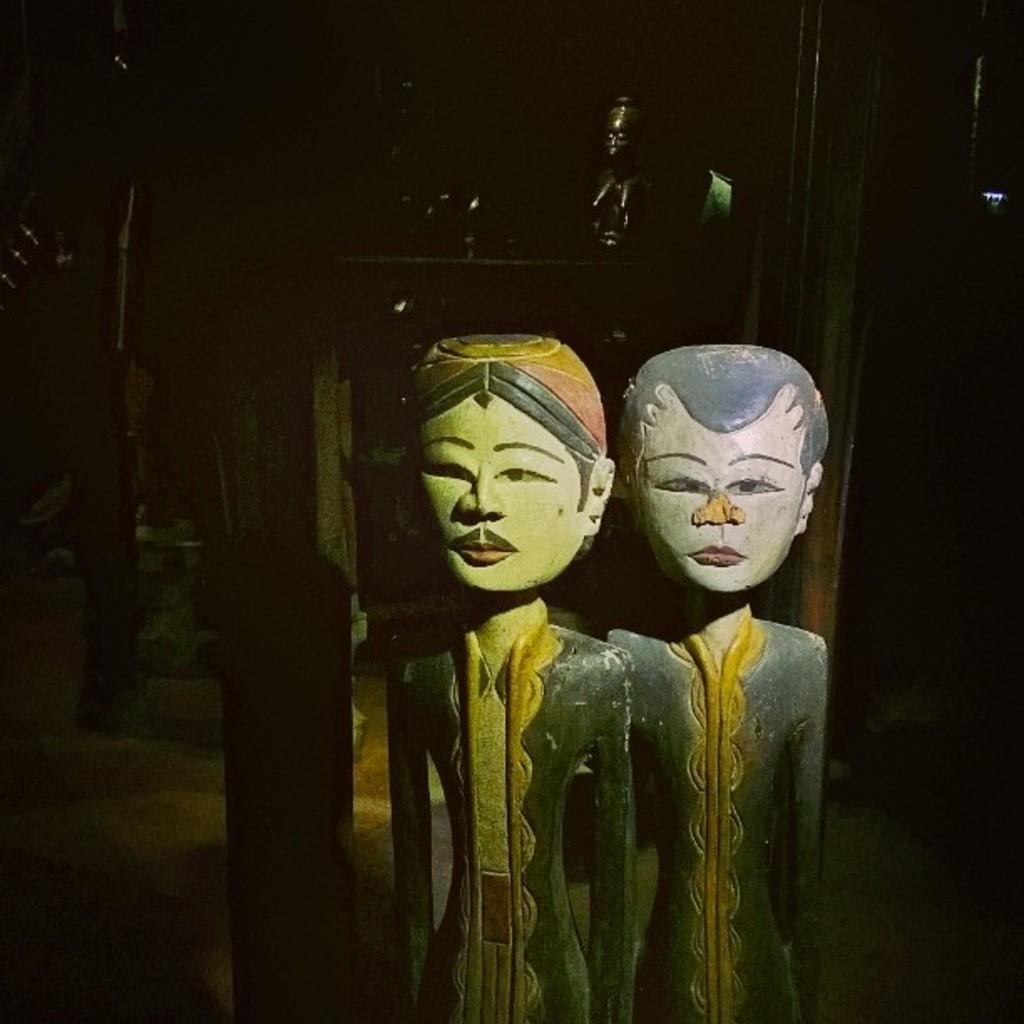What objects are present in the image? There are statues in the image. What can be observed about the background of the image? The background of the image is dark. What type of range can be seen in the image? There is no range present in the image. What kind of string is attached to the statues in the image? There is no string attached to the statues in the image. 